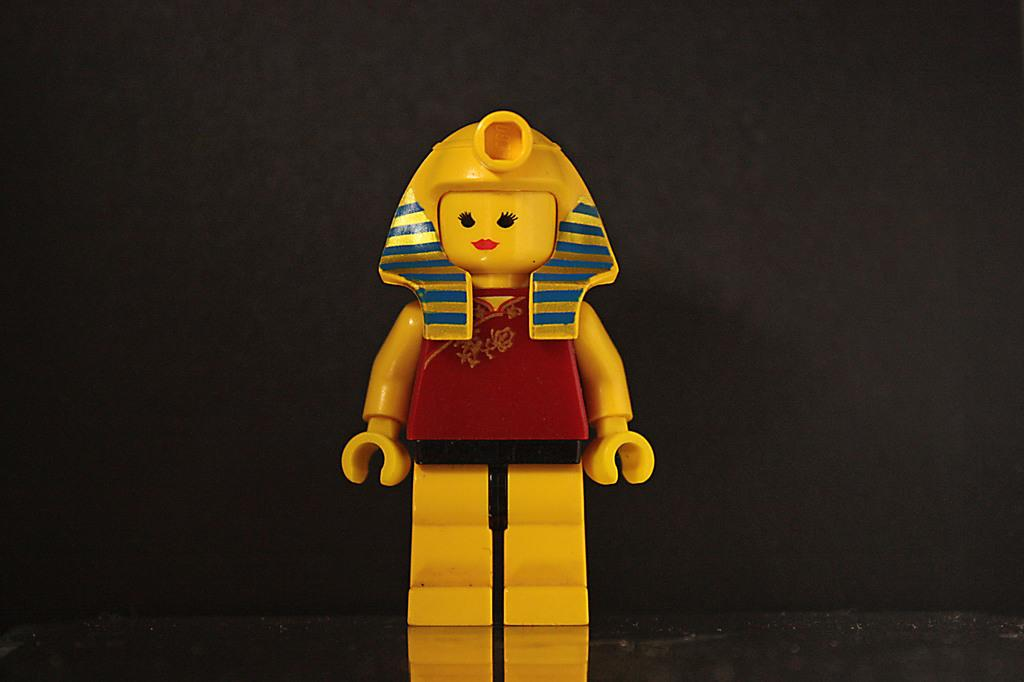What type of toy is in the image? There is a Lego toy in the image. What colors can be seen on the Lego toy? The Lego toy has yellow, black, red, and blue colors. What is the color of the background in the image? The background of the image is dark. Can you tell me how many balloons are tied to the Lego toy in the image? There are no balloons present in the image; it only features a Lego toy with various colors. 